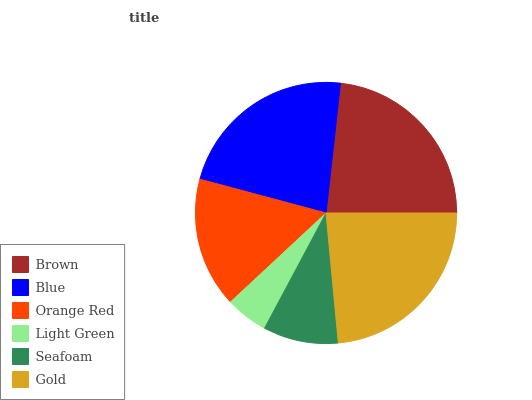Is Light Green the minimum?
Answer yes or no. Yes. Is Gold the maximum?
Answer yes or no. Yes. Is Blue the minimum?
Answer yes or no. No. Is Blue the maximum?
Answer yes or no. No. Is Brown greater than Blue?
Answer yes or no. Yes. Is Blue less than Brown?
Answer yes or no. Yes. Is Blue greater than Brown?
Answer yes or no. No. Is Brown less than Blue?
Answer yes or no. No. Is Blue the high median?
Answer yes or no. Yes. Is Orange Red the low median?
Answer yes or no. Yes. Is Light Green the high median?
Answer yes or no. No. Is Gold the low median?
Answer yes or no. No. 